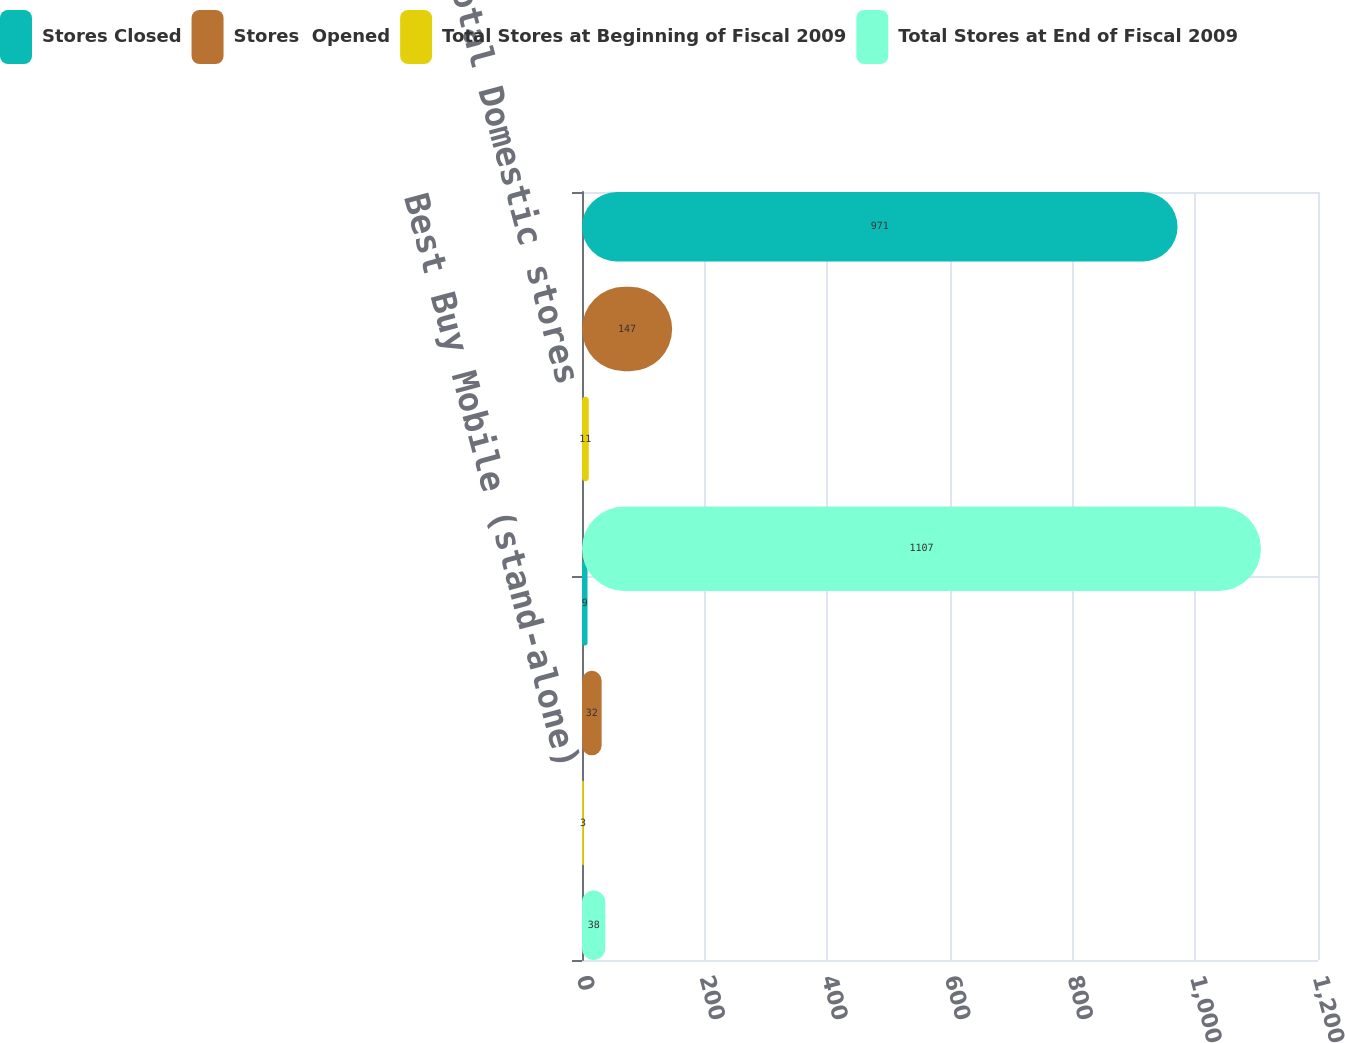Convert chart. <chart><loc_0><loc_0><loc_500><loc_500><stacked_bar_chart><ecel><fcel>Best Buy Mobile (stand-alone)<fcel>Total Domestic stores<nl><fcel>Stores Closed<fcel>9<fcel>971<nl><fcel>Stores  Opened<fcel>32<fcel>147<nl><fcel>Total Stores at Beginning of Fiscal 2009<fcel>3<fcel>11<nl><fcel>Total Stores at End of Fiscal 2009<fcel>38<fcel>1107<nl></chart> 